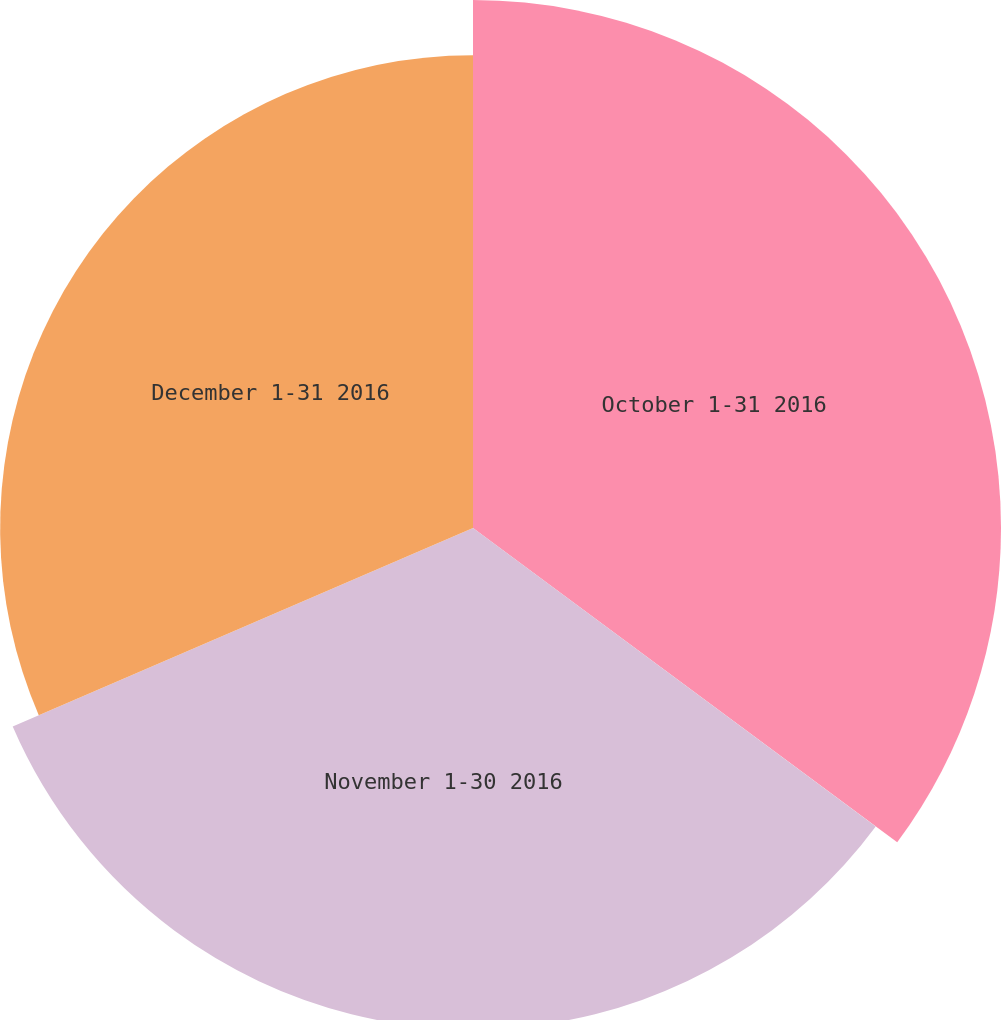Convert chart to OTSL. <chart><loc_0><loc_0><loc_500><loc_500><pie_chart><fcel>October 1-31 2016<fcel>November 1-30 2016<fcel>December 1-31 2016<nl><fcel>35.15%<fcel>33.37%<fcel>31.48%<nl></chart> 